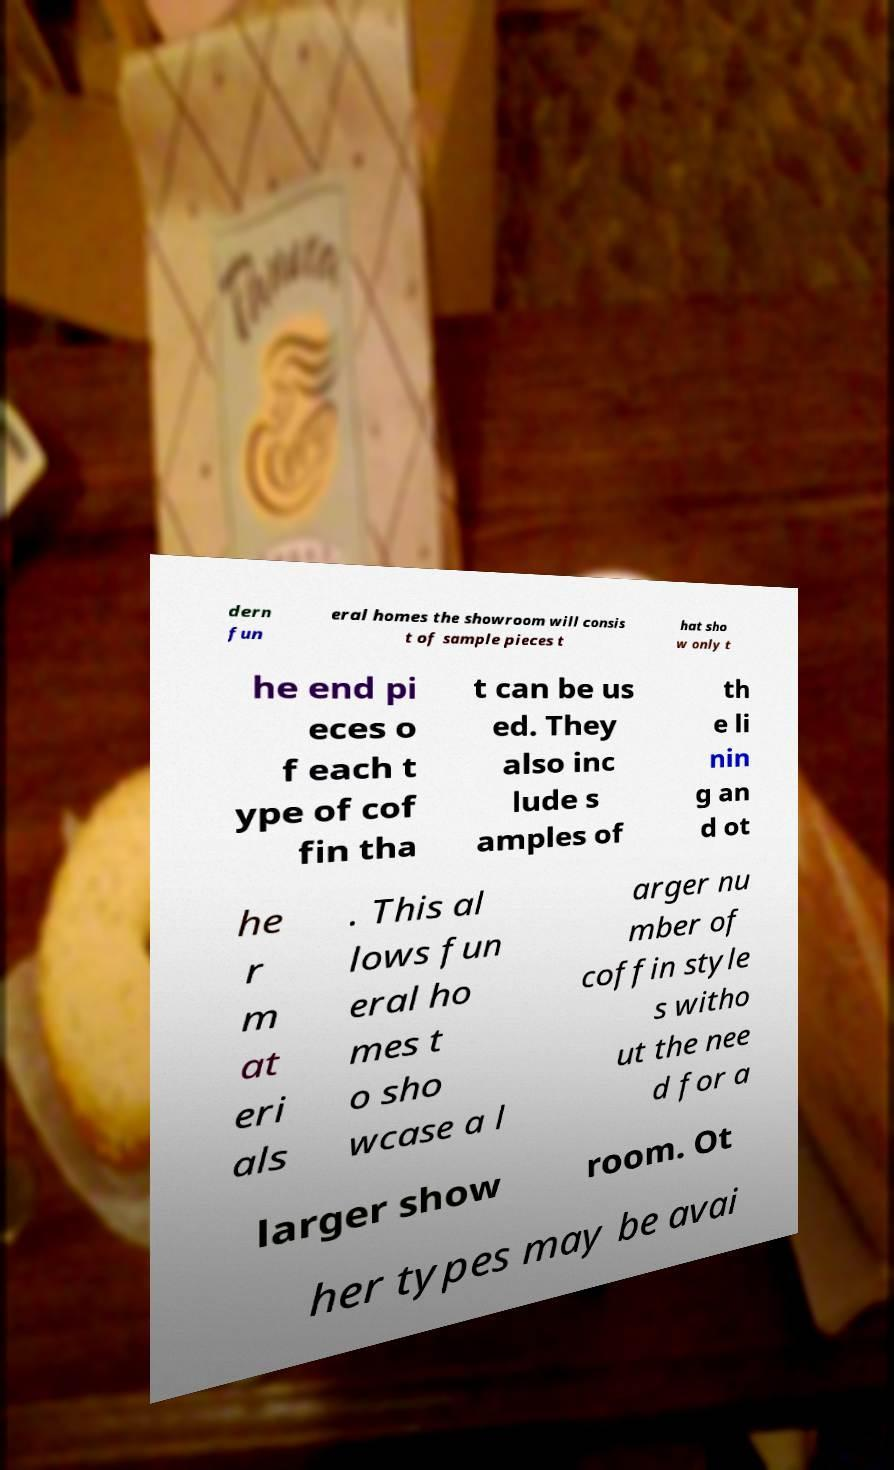Please read and relay the text visible in this image. What does it say? dern fun eral homes the showroom will consis t of sample pieces t hat sho w only t he end pi eces o f each t ype of cof fin tha t can be us ed. They also inc lude s amples of th e li nin g an d ot he r m at eri als . This al lows fun eral ho mes t o sho wcase a l arger nu mber of coffin style s witho ut the nee d for a larger show room. Ot her types may be avai 